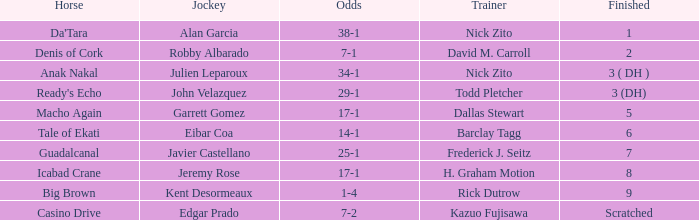What is the Finished place for da'tara trained by Nick zito? 1.0. 